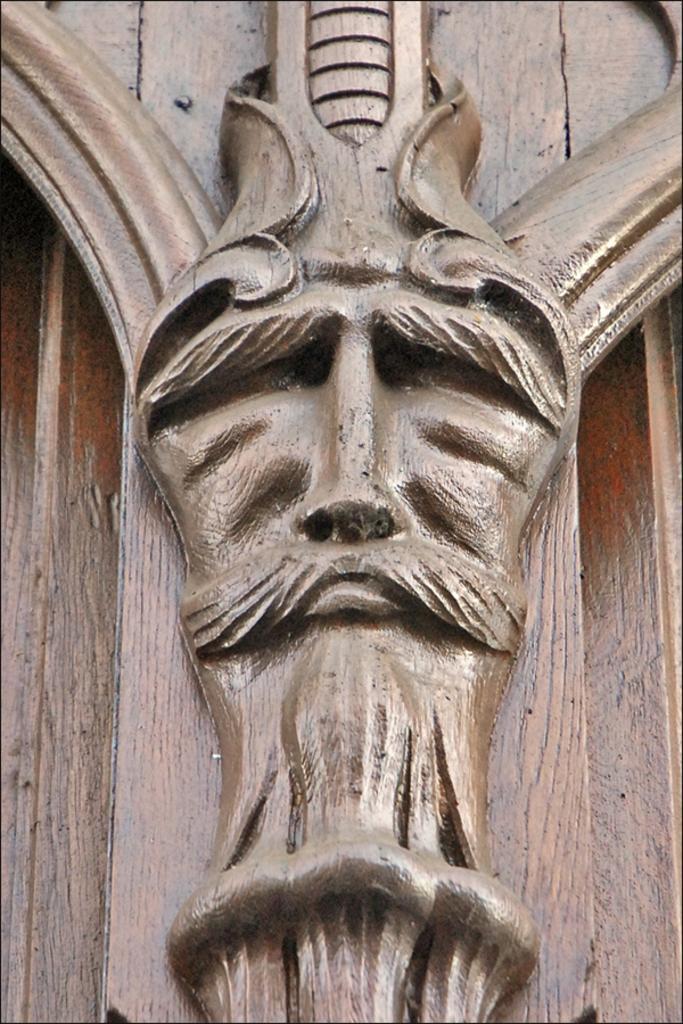Could you give a brief overview of what you see in this image? In this image there is a sculpture. 